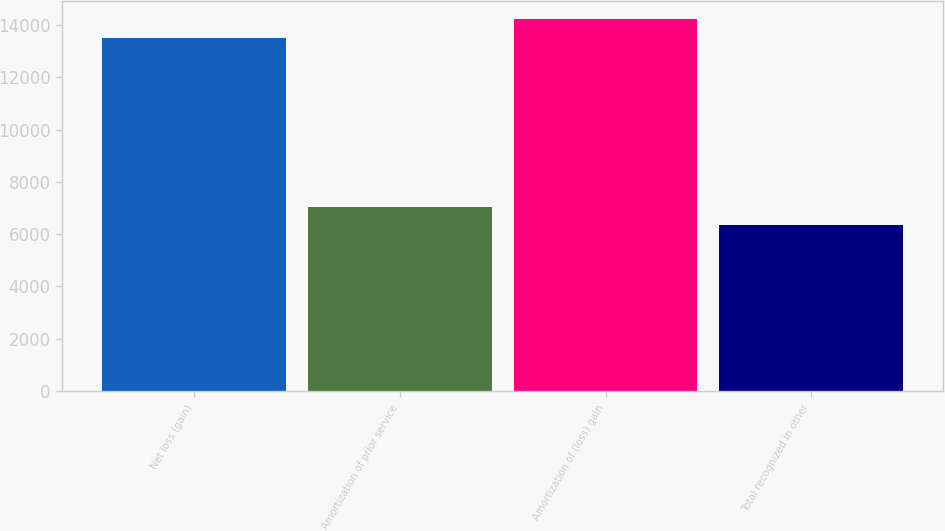Convert chart. <chart><loc_0><loc_0><loc_500><loc_500><bar_chart><fcel>Net loss (gain)<fcel>Amortization of prior service<fcel>Amortization of (loss) gain<fcel>Total recognized in other<nl><fcel>13490<fcel>7052.1<fcel>14211.1<fcel>6331<nl></chart> 